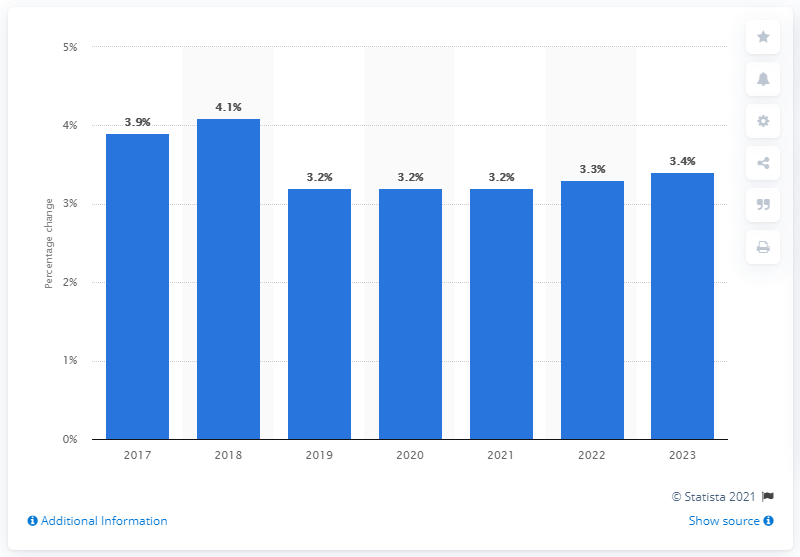Indicate a few pertinent items in this graphic. The forecast increase in wages and salaries in 2018 was expected to be 4.1%. 